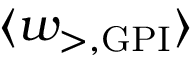Convert formula to latex. <formula><loc_0><loc_0><loc_500><loc_500>{ \langle w _ { > , G P I } \rangle }</formula> 